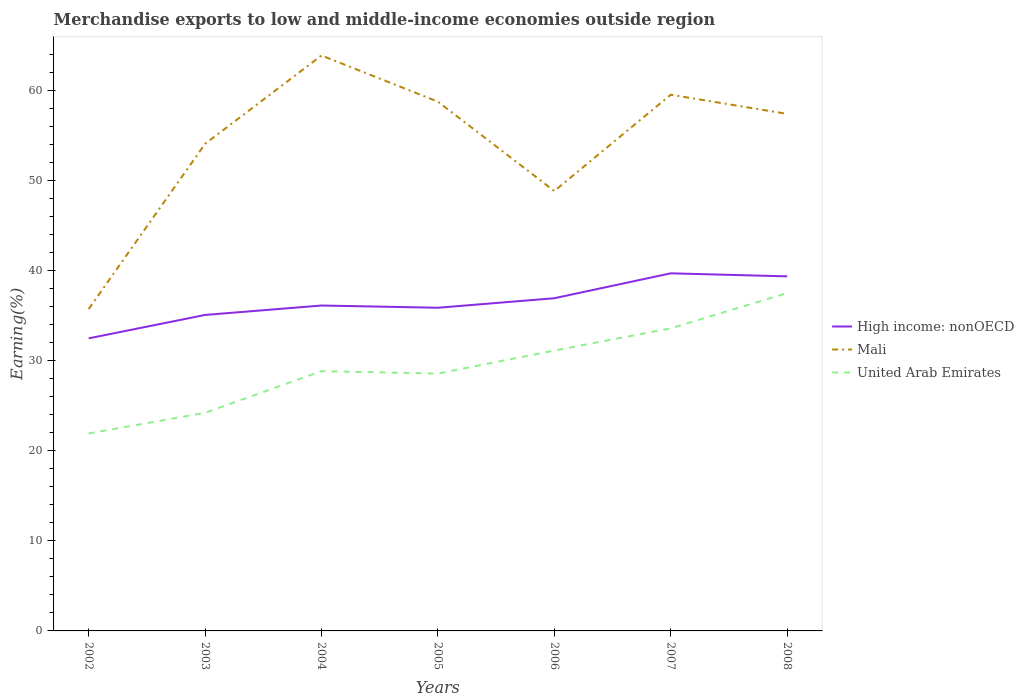Is the number of lines equal to the number of legend labels?
Your response must be concise. Yes. Across all years, what is the maximum percentage of amount earned from merchandise exports in Mali?
Ensure brevity in your answer.  35.72. What is the total percentage of amount earned from merchandise exports in United Arab Emirates in the graph?
Your response must be concise. -4.75. What is the difference between the highest and the second highest percentage of amount earned from merchandise exports in Mali?
Your answer should be compact. 28.14. What is the difference between the highest and the lowest percentage of amount earned from merchandise exports in High income: nonOECD?
Make the answer very short. 3. Is the percentage of amount earned from merchandise exports in High income: nonOECD strictly greater than the percentage of amount earned from merchandise exports in United Arab Emirates over the years?
Provide a short and direct response. No. How many lines are there?
Ensure brevity in your answer.  3. What is the difference between two consecutive major ticks on the Y-axis?
Offer a terse response. 10. Does the graph contain any zero values?
Offer a very short reply. No. Does the graph contain grids?
Ensure brevity in your answer.  No. Where does the legend appear in the graph?
Keep it short and to the point. Center right. How many legend labels are there?
Provide a succinct answer. 3. What is the title of the graph?
Keep it short and to the point. Merchandise exports to low and middle-income economies outside region. Does "Mozambique" appear as one of the legend labels in the graph?
Provide a succinct answer. No. What is the label or title of the X-axis?
Your answer should be compact. Years. What is the label or title of the Y-axis?
Offer a very short reply. Earning(%). What is the Earning(%) in High income: nonOECD in 2002?
Keep it short and to the point. 32.47. What is the Earning(%) of Mali in 2002?
Provide a short and direct response. 35.72. What is the Earning(%) of United Arab Emirates in 2002?
Make the answer very short. 21.91. What is the Earning(%) in High income: nonOECD in 2003?
Provide a short and direct response. 35.07. What is the Earning(%) of Mali in 2003?
Offer a terse response. 54.05. What is the Earning(%) in United Arab Emirates in 2003?
Offer a very short reply. 24.21. What is the Earning(%) of High income: nonOECD in 2004?
Give a very brief answer. 36.11. What is the Earning(%) of Mali in 2004?
Give a very brief answer. 63.86. What is the Earning(%) in United Arab Emirates in 2004?
Your answer should be very brief. 28.83. What is the Earning(%) of High income: nonOECD in 2005?
Keep it short and to the point. 35.87. What is the Earning(%) of Mali in 2005?
Make the answer very short. 58.74. What is the Earning(%) of United Arab Emirates in 2005?
Make the answer very short. 28.56. What is the Earning(%) in High income: nonOECD in 2006?
Offer a very short reply. 36.92. What is the Earning(%) in Mali in 2006?
Provide a succinct answer. 48.82. What is the Earning(%) of United Arab Emirates in 2006?
Provide a short and direct response. 31.12. What is the Earning(%) in High income: nonOECD in 2007?
Your answer should be very brief. 39.69. What is the Earning(%) in Mali in 2007?
Offer a terse response. 59.5. What is the Earning(%) of United Arab Emirates in 2007?
Make the answer very short. 33.58. What is the Earning(%) in High income: nonOECD in 2008?
Ensure brevity in your answer.  39.35. What is the Earning(%) of Mali in 2008?
Provide a succinct answer. 57.38. What is the Earning(%) in United Arab Emirates in 2008?
Your answer should be compact. 37.5. Across all years, what is the maximum Earning(%) in High income: nonOECD?
Provide a short and direct response. 39.69. Across all years, what is the maximum Earning(%) in Mali?
Give a very brief answer. 63.86. Across all years, what is the maximum Earning(%) of United Arab Emirates?
Your answer should be compact. 37.5. Across all years, what is the minimum Earning(%) in High income: nonOECD?
Ensure brevity in your answer.  32.47. Across all years, what is the minimum Earning(%) of Mali?
Provide a succinct answer. 35.72. Across all years, what is the minimum Earning(%) of United Arab Emirates?
Offer a terse response. 21.91. What is the total Earning(%) in High income: nonOECD in the graph?
Keep it short and to the point. 255.47. What is the total Earning(%) in Mali in the graph?
Provide a short and direct response. 378.07. What is the total Earning(%) of United Arab Emirates in the graph?
Your answer should be very brief. 205.7. What is the difference between the Earning(%) of High income: nonOECD in 2002 and that in 2003?
Provide a short and direct response. -2.6. What is the difference between the Earning(%) of Mali in 2002 and that in 2003?
Ensure brevity in your answer.  -18.33. What is the difference between the Earning(%) in United Arab Emirates in 2002 and that in 2003?
Your answer should be very brief. -2.29. What is the difference between the Earning(%) of High income: nonOECD in 2002 and that in 2004?
Offer a terse response. -3.64. What is the difference between the Earning(%) of Mali in 2002 and that in 2004?
Make the answer very short. -28.14. What is the difference between the Earning(%) in United Arab Emirates in 2002 and that in 2004?
Your response must be concise. -6.92. What is the difference between the Earning(%) of High income: nonOECD in 2002 and that in 2005?
Your answer should be very brief. -3.4. What is the difference between the Earning(%) in Mali in 2002 and that in 2005?
Make the answer very short. -23.02. What is the difference between the Earning(%) in United Arab Emirates in 2002 and that in 2005?
Your answer should be compact. -6.65. What is the difference between the Earning(%) of High income: nonOECD in 2002 and that in 2006?
Make the answer very short. -4.45. What is the difference between the Earning(%) of Mali in 2002 and that in 2006?
Your answer should be very brief. -13.1. What is the difference between the Earning(%) of United Arab Emirates in 2002 and that in 2006?
Offer a terse response. -9.2. What is the difference between the Earning(%) of High income: nonOECD in 2002 and that in 2007?
Your answer should be compact. -7.22. What is the difference between the Earning(%) of Mali in 2002 and that in 2007?
Ensure brevity in your answer.  -23.79. What is the difference between the Earning(%) in United Arab Emirates in 2002 and that in 2007?
Offer a terse response. -11.67. What is the difference between the Earning(%) of High income: nonOECD in 2002 and that in 2008?
Provide a succinct answer. -6.88. What is the difference between the Earning(%) in Mali in 2002 and that in 2008?
Provide a short and direct response. -21.66. What is the difference between the Earning(%) in United Arab Emirates in 2002 and that in 2008?
Give a very brief answer. -15.58. What is the difference between the Earning(%) in High income: nonOECD in 2003 and that in 2004?
Your answer should be very brief. -1.05. What is the difference between the Earning(%) in Mali in 2003 and that in 2004?
Offer a terse response. -9.81. What is the difference between the Earning(%) in United Arab Emirates in 2003 and that in 2004?
Keep it short and to the point. -4.62. What is the difference between the Earning(%) in High income: nonOECD in 2003 and that in 2005?
Give a very brief answer. -0.8. What is the difference between the Earning(%) of Mali in 2003 and that in 2005?
Give a very brief answer. -4.68. What is the difference between the Earning(%) in United Arab Emirates in 2003 and that in 2005?
Give a very brief answer. -4.35. What is the difference between the Earning(%) of High income: nonOECD in 2003 and that in 2006?
Ensure brevity in your answer.  -1.86. What is the difference between the Earning(%) in Mali in 2003 and that in 2006?
Keep it short and to the point. 5.23. What is the difference between the Earning(%) of United Arab Emirates in 2003 and that in 2006?
Provide a succinct answer. -6.91. What is the difference between the Earning(%) in High income: nonOECD in 2003 and that in 2007?
Keep it short and to the point. -4.62. What is the difference between the Earning(%) in Mali in 2003 and that in 2007?
Your answer should be compact. -5.45. What is the difference between the Earning(%) of United Arab Emirates in 2003 and that in 2007?
Ensure brevity in your answer.  -9.37. What is the difference between the Earning(%) of High income: nonOECD in 2003 and that in 2008?
Keep it short and to the point. -4.28. What is the difference between the Earning(%) in Mali in 2003 and that in 2008?
Provide a short and direct response. -3.33. What is the difference between the Earning(%) in United Arab Emirates in 2003 and that in 2008?
Your response must be concise. -13.29. What is the difference between the Earning(%) in High income: nonOECD in 2004 and that in 2005?
Offer a terse response. 0.25. What is the difference between the Earning(%) of Mali in 2004 and that in 2005?
Offer a very short reply. 5.13. What is the difference between the Earning(%) in United Arab Emirates in 2004 and that in 2005?
Offer a very short reply. 0.27. What is the difference between the Earning(%) of High income: nonOECD in 2004 and that in 2006?
Keep it short and to the point. -0.81. What is the difference between the Earning(%) of Mali in 2004 and that in 2006?
Ensure brevity in your answer.  15.04. What is the difference between the Earning(%) of United Arab Emirates in 2004 and that in 2006?
Give a very brief answer. -2.29. What is the difference between the Earning(%) of High income: nonOECD in 2004 and that in 2007?
Keep it short and to the point. -3.57. What is the difference between the Earning(%) in Mali in 2004 and that in 2007?
Provide a short and direct response. 4.36. What is the difference between the Earning(%) of United Arab Emirates in 2004 and that in 2007?
Give a very brief answer. -4.75. What is the difference between the Earning(%) in High income: nonOECD in 2004 and that in 2008?
Offer a terse response. -3.24. What is the difference between the Earning(%) of Mali in 2004 and that in 2008?
Keep it short and to the point. 6.48. What is the difference between the Earning(%) in United Arab Emirates in 2004 and that in 2008?
Offer a terse response. -8.67. What is the difference between the Earning(%) of High income: nonOECD in 2005 and that in 2006?
Your response must be concise. -1.06. What is the difference between the Earning(%) of Mali in 2005 and that in 2006?
Keep it short and to the point. 9.92. What is the difference between the Earning(%) in United Arab Emirates in 2005 and that in 2006?
Your answer should be very brief. -2.55. What is the difference between the Earning(%) of High income: nonOECD in 2005 and that in 2007?
Give a very brief answer. -3.82. What is the difference between the Earning(%) in Mali in 2005 and that in 2007?
Provide a short and direct response. -0.77. What is the difference between the Earning(%) of United Arab Emirates in 2005 and that in 2007?
Provide a short and direct response. -5.02. What is the difference between the Earning(%) in High income: nonOECD in 2005 and that in 2008?
Your answer should be very brief. -3.48. What is the difference between the Earning(%) in Mali in 2005 and that in 2008?
Provide a short and direct response. 1.36. What is the difference between the Earning(%) of United Arab Emirates in 2005 and that in 2008?
Keep it short and to the point. -8.94. What is the difference between the Earning(%) in High income: nonOECD in 2006 and that in 2007?
Provide a short and direct response. -2.76. What is the difference between the Earning(%) of Mali in 2006 and that in 2007?
Provide a short and direct response. -10.68. What is the difference between the Earning(%) in United Arab Emirates in 2006 and that in 2007?
Make the answer very short. -2.46. What is the difference between the Earning(%) in High income: nonOECD in 2006 and that in 2008?
Your answer should be very brief. -2.43. What is the difference between the Earning(%) in Mali in 2006 and that in 2008?
Provide a short and direct response. -8.56. What is the difference between the Earning(%) in United Arab Emirates in 2006 and that in 2008?
Provide a short and direct response. -6.38. What is the difference between the Earning(%) of High income: nonOECD in 2007 and that in 2008?
Your answer should be compact. 0.34. What is the difference between the Earning(%) of Mali in 2007 and that in 2008?
Your answer should be very brief. 2.12. What is the difference between the Earning(%) in United Arab Emirates in 2007 and that in 2008?
Make the answer very short. -3.92. What is the difference between the Earning(%) of High income: nonOECD in 2002 and the Earning(%) of Mali in 2003?
Your answer should be compact. -21.58. What is the difference between the Earning(%) in High income: nonOECD in 2002 and the Earning(%) in United Arab Emirates in 2003?
Your response must be concise. 8.26. What is the difference between the Earning(%) in Mali in 2002 and the Earning(%) in United Arab Emirates in 2003?
Give a very brief answer. 11.51. What is the difference between the Earning(%) in High income: nonOECD in 2002 and the Earning(%) in Mali in 2004?
Make the answer very short. -31.39. What is the difference between the Earning(%) of High income: nonOECD in 2002 and the Earning(%) of United Arab Emirates in 2004?
Your answer should be compact. 3.64. What is the difference between the Earning(%) of Mali in 2002 and the Earning(%) of United Arab Emirates in 2004?
Offer a terse response. 6.89. What is the difference between the Earning(%) in High income: nonOECD in 2002 and the Earning(%) in Mali in 2005?
Make the answer very short. -26.27. What is the difference between the Earning(%) of High income: nonOECD in 2002 and the Earning(%) of United Arab Emirates in 2005?
Your answer should be very brief. 3.91. What is the difference between the Earning(%) in Mali in 2002 and the Earning(%) in United Arab Emirates in 2005?
Give a very brief answer. 7.16. What is the difference between the Earning(%) of High income: nonOECD in 2002 and the Earning(%) of Mali in 2006?
Give a very brief answer. -16.35. What is the difference between the Earning(%) of High income: nonOECD in 2002 and the Earning(%) of United Arab Emirates in 2006?
Your answer should be compact. 1.35. What is the difference between the Earning(%) in Mali in 2002 and the Earning(%) in United Arab Emirates in 2006?
Make the answer very short. 4.6. What is the difference between the Earning(%) of High income: nonOECD in 2002 and the Earning(%) of Mali in 2007?
Provide a short and direct response. -27.03. What is the difference between the Earning(%) in High income: nonOECD in 2002 and the Earning(%) in United Arab Emirates in 2007?
Your answer should be very brief. -1.11. What is the difference between the Earning(%) in Mali in 2002 and the Earning(%) in United Arab Emirates in 2007?
Your response must be concise. 2.14. What is the difference between the Earning(%) in High income: nonOECD in 2002 and the Earning(%) in Mali in 2008?
Your answer should be compact. -24.91. What is the difference between the Earning(%) of High income: nonOECD in 2002 and the Earning(%) of United Arab Emirates in 2008?
Give a very brief answer. -5.03. What is the difference between the Earning(%) of Mali in 2002 and the Earning(%) of United Arab Emirates in 2008?
Ensure brevity in your answer.  -1.78. What is the difference between the Earning(%) in High income: nonOECD in 2003 and the Earning(%) in Mali in 2004?
Offer a terse response. -28.8. What is the difference between the Earning(%) in High income: nonOECD in 2003 and the Earning(%) in United Arab Emirates in 2004?
Your response must be concise. 6.24. What is the difference between the Earning(%) in Mali in 2003 and the Earning(%) in United Arab Emirates in 2004?
Make the answer very short. 25.22. What is the difference between the Earning(%) of High income: nonOECD in 2003 and the Earning(%) of Mali in 2005?
Ensure brevity in your answer.  -23.67. What is the difference between the Earning(%) of High income: nonOECD in 2003 and the Earning(%) of United Arab Emirates in 2005?
Your answer should be compact. 6.5. What is the difference between the Earning(%) of Mali in 2003 and the Earning(%) of United Arab Emirates in 2005?
Provide a succinct answer. 25.49. What is the difference between the Earning(%) of High income: nonOECD in 2003 and the Earning(%) of Mali in 2006?
Give a very brief answer. -13.75. What is the difference between the Earning(%) of High income: nonOECD in 2003 and the Earning(%) of United Arab Emirates in 2006?
Make the answer very short. 3.95. What is the difference between the Earning(%) of Mali in 2003 and the Earning(%) of United Arab Emirates in 2006?
Offer a terse response. 22.94. What is the difference between the Earning(%) of High income: nonOECD in 2003 and the Earning(%) of Mali in 2007?
Your answer should be very brief. -24.44. What is the difference between the Earning(%) in High income: nonOECD in 2003 and the Earning(%) in United Arab Emirates in 2007?
Ensure brevity in your answer.  1.49. What is the difference between the Earning(%) in Mali in 2003 and the Earning(%) in United Arab Emirates in 2007?
Your response must be concise. 20.47. What is the difference between the Earning(%) of High income: nonOECD in 2003 and the Earning(%) of Mali in 2008?
Offer a terse response. -22.31. What is the difference between the Earning(%) in High income: nonOECD in 2003 and the Earning(%) in United Arab Emirates in 2008?
Your answer should be very brief. -2.43. What is the difference between the Earning(%) in Mali in 2003 and the Earning(%) in United Arab Emirates in 2008?
Your response must be concise. 16.55. What is the difference between the Earning(%) of High income: nonOECD in 2004 and the Earning(%) of Mali in 2005?
Make the answer very short. -22.62. What is the difference between the Earning(%) of High income: nonOECD in 2004 and the Earning(%) of United Arab Emirates in 2005?
Your answer should be very brief. 7.55. What is the difference between the Earning(%) of Mali in 2004 and the Earning(%) of United Arab Emirates in 2005?
Provide a succinct answer. 35.3. What is the difference between the Earning(%) in High income: nonOECD in 2004 and the Earning(%) in Mali in 2006?
Make the answer very short. -12.71. What is the difference between the Earning(%) in High income: nonOECD in 2004 and the Earning(%) in United Arab Emirates in 2006?
Keep it short and to the point. 5. What is the difference between the Earning(%) of Mali in 2004 and the Earning(%) of United Arab Emirates in 2006?
Your response must be concise. 32.75. What is the difference between the Earning(%) in High income: nonOECD in 2004 and the Earning(%) in Mali in 2007?
Your response must be concise. -23.39. What is the difference between the Earning(%) in High income: nonOECD in 2004 and the Earning(%) in United Arab Emirates in 2007?
Your answer should be very brief. 2.53. What is the difference between the Earning(%) in Mali in 2004 and the Earning(%) in United Arab Emirates in 2007?
Offer a terse response. 30.28. What is the difference between the Earning(%) in High income: nonOECD in 2004 and the Earning(%) in Mali in 2008?
Offer a terse response. -21.27. What is the difference between the Earning(%) of High income: nonOECD in 2004 and the Earning(%) of United Arab Emirates in 2008?
Your answer should be compact. -1.39. What is the difference between the Earning(%) of Mali in 2004 and the Earning(%) of United Arab Emirates in 2008?
Give a very brief answer. 26.36. What is the difference between the Earning(%) of High income: nonOECD in 2005 and the Earning(%) of Mali in 2006?
Your answer should be very brief. -12.95. What is the difference between the Earning(%) in High income: nonOECD in 2005 and the Earning(%) in United Arab Emirates in 2006?
Make the answer very short. 4.75. What is the difference between the Earning(%) in Mali in 2005 and the Earning(%) in United Arab Emirates in 2006?
Provide a succinct answer. 27.62. What is the difference between the Earning(%) of High income: nonOECD in 2005 and the Earning(%) of Mali in 2007?
Your answer should be very brief. -23.64. What is the difference between the Earning(%) of High income: nonOECD in 2005 and the Earning(%) of United Arab Emirates in 2007?
Provide a succinct answer. 2.29. What is the difference between the Earning(%) in Mali in 2005 and the Earning(%) in United Arab Emirates in 2007?
Keep it short and to the point. 25.16. What is the difference between the Earning(%) in High income: nonOECD in 2005 and the Earning(%) in Mali in 2008?
Make the answer very short. -21.51. What is the difference between the Earning(%) in High income: nonOECD in 2005 and the Earning(%) in United Arab Emirates in 2008?
Offer a very short reply. -1.63. What is the difference between the Earning(%) in Mali in 2005 and the Earning(%) in United Arab Emirates in 2008?
Ensure brevity in your answer.  21.24. What is the difference between the Earning(%) of High income: nonOECD in 2006 and the Earning(%) of Mali in 2007?
Your answer should be compact. -22.58. What is the difference between the Earning(%) in High income: nonOECD in 2006 and the Earning(%) in United Arab Emirates in 2007?
Your answer should be compact. 3.34. What is the difference between the Earning(%) in Mali in 2006 and the Earning(%) in United Arab Emirates in 2007?
Ensure brevity in your answer.  15.24. What is the difference between the Earning(%) of High income: nonOECD in 2006 and the Earning(%) of Mali in 2008?
Your answer should be very brief. -20.46. What is the difference between the Earning(%) of High income: nonOECD in 2006 and the Earning(%) of United Arab Emirates in 2008?
Give a very brief answer. -0.58. What is the difference between the Earning(%) of Mali in 2006 and the Earning(%) of United Arab Emirates in 2008?
Provide a short and direct response. 11.32. What is the difference between the Earning(%) in High income: nonOECD in 2007 and the Earning(%) in Mali in 2008?
Your answer should be compact. -17.69. What is the difference between the Earning(%) in High income: nonOECD in 2007 and the Earning(%) in United Arab Emirates in 2008?
Offer a terse response. 2.19. What is the difference between the Earning(%) in Mali in 2007 and the Earning(%) in United Arab Emirates in 2008?
Provide a short and direct response. 22.01. What is the average Earning(%) of High income: nonOECD per year?
Keep it short and to the point. 36.5. What is the average Earning(%) in Mali per year?
Give a very brief answer. 54.01. What is the average Earning(%) in United Arab Emirates per year?
Your answer should be very brief. 29.39. In the year 2002, what is the difference between the Earning(%) of High income: nonOECD and Earning(%) of Mali?
Your answer should be very brief. -3.25. In the year 2002, what is the difference between the Earning(%) in High income: nonOECD and Earning(%) in United Arab Emirates?
Give a very brief answer. 10.56. In the year 2002, what is the difference between the Earning(%) of Mali and Earning(%) of United Arab Emirates?
Provide a succinct answer. 13.8. In the year 2003, what is the difference between the Earning(%) in High income: nonOECD and Earning(%) in Mali?
Keep it short and to the point. -18.99. In the year 2003, what is the difference between the Earning(%) in High income: nonOECD and Earning(%) in United Arab Emirates?
Offer a terse response. 10.86. In the year 2003, what is the difference between the Earning(%) of Mali and Earning(%) of United Arab Emirates?
Your response must be concise. 29.85. In the year 2004, what is the difference between the Earning(%) of High income: nonOECD and Earning(%) of Mali?
Ensure brevity in your answer.  -27.75. In the year 2004, what is the difference between the Earning(%) in High income: nonOECD and Earning(%) in United Arab Emirates?
Provide a succinct answer. 7.28. In the year 2004, what is the difference between the Earning(%) of Mali and Earning(%) of United Arab Emirates?
Keep it short and to the point. 35.03. In the year 2005, what is the difference between the Earning(%) in High income: nonOECD and Earning(%) in Mali?
Offer a terse response. -22.87. In the year 2005, what is the difference between the Earning(%) in High income: nonOECD and Earning(%) in United Arab Emirates?
Provide a short and direct response. 7.3. In the year 2005, what is the difference between the Earning(%) of Mali and Earning(%) of United Arab Emirates?
Your answer should be very brief. 30.17. In the year 2006, what is the difference between the Earning(%) in High income: nonOECD and Earning(%) in Mali?
Offer a terse response. -11.9. In the year 2006, what is the difference between the Earning(%) in High income: nonOECD and Earning(%) in United Arab Emirates?
Your answer should be compact. 5.81. In the year 2006, what is the difference between the Earning(%) in Mali and Earning(%) in United Arab Emirates?
Your answer should be compact. 17.7. In the year 2007, what is the difference between the Earning(%) of High income: nonOECD and Earning(%) of Mali?
Your answer should be very brief. -19.82. In the year 2007, what is the difference between the Earning(%) of High income: nonOECD and Earning(%) of United Arab Emirates?
Provide a short and direct response. 6.11. In the year 2007, what is the difference between the Earning(%) of Mali and Earning(%) of United Arab Emirates?
Your answer should be compact. 25.92. In the year 2008, what is the difference between the Earning(%) in High income: nonOECD and Earning(%) in Mali?
Your answer should be compact. -18.03. In the year 2008, what is the difference between the Earning(%) of High income: nonOECD and Earning(%) of United Arab Emirates?
Your response must be concise. 1.85. In the year 2008, what is the difference between the Earning(%) of Mali and Earning(%) of United Arab Emirates?
Provide a succinct answer. 19.88. What is the ratio of the Earning(%) in High income: nonOECD in 2002 to that in 2003?
Offer a terse response. 0.93. What is the ratio of the Earning(%) of Mali in 2002 to that in 2003?
Your answer should be very brief. 0.66. What is the ratio of the Earning(%) in United Arab Emirates in 2002 to that in 2003?
Give a very brief answer. 0.91. What is the ratio of the Earning(%) in High income: nonOECD in 2002 to that in 2004?
Ensure brevity in your answer.  0.9. What is the ratio of the Earning(%) of Mali in 2002 to that in 2004?
Provide a succinct answer. 0.56. What is the ratio of the Earning(%) in United Arab Emirates in 2002 to that in 2004?
Make the answer very short. 0.76. What is the ratio of the Earning(%) of High income: nonOECD in 2002 to that in 2005?
Your response must be concise. 0.91. What is the ratio of the Earning(%) in Mali in 2002 to that in 2005?
Provide a short and direct response. 0.61. What is the ratio of the Earning(%) in United Arab Emirates in 2002 to that in 2005?
Your answer should be compact. 0.77. What is the ratio of the Earning(%) of High income: nonOECD in 2002 to that in 2006?
Make the answer very short. 0.88. What is the ratio of the Earning(%) of Mali in 2002 to that in 2006?
Provide a short and direct response. 0.73. What is the ratio of the Earning(%) of United Arab Emirates in 2002 to that in 2006?
Keep it short and to the point. 0.7. What is the ratio of the Earning(%) in High income: nonOECD in 2002 to that in 2007?
Ensure brevity in your answer.  0.82. What is the ratio of the Earning(%) of Mali in 2002 to that in 2007?
Your response must be concise. 0.6. What is the ratio of the Earning(%) of United Arab Emirates in 2002 to that in 2007?
Provide a succinct answer. 0.65. What is the ratio of the Earning(%) in High income: nonOECD in 2002 to that in 2008?
Your answer should be compact. 0.83. What is the ratio of the Earning(%) of Mali in 2002 to that in 2008?
Make the answer very short. 0.62. What is the ratio of the Earning(%) in United Arab Emirates in 2002 to that in 2008?
Make the answer very short. 0.58. What is the ratio of the Earning(%) in Mali in 2003 to that in 2004?
Offer a very short reply. 0.85. What is the ratio of the Earning(%) of United Arab Emirates in 2003 to that in 2004?
Offer a terse response. 0.84. What is the ratio of the Earning(%) in High income: nonOECD in 2003 to that in 2005?
Give a very brief answer. 0.98. What is the ratio of the Earning(%) in Mali in 2003 to that in 2005?
Your answer should be very brief. 0.92. What is the ratio of the Earning(%) in United Arab Emirates in 2003 to that in 2005?
Offer a very short reply. 0.85. What is the ratio of the Earning(%) of High income: nonOECD in 2003 to that in 2006?
Your answer should be very brief. 0.95. What is the ratio of the Earning(%) of Mali in 2003 to that in 2006?
Provide a short and direct response. 1.11. What is the ratio of the Earning(%) of United Arab Emirates in 2003 to that in 2006?
Offer a very short reply. 0.78. What is the ratio of the Earning(%) of High income: nonOECD in 2003 to that in 2007?
Offer a terse response. 0.88. What is the ratio of the Earning(%) in Mali in 2003 to that in 2007?
Give a very brief answer. 0.91. What is the ratio of the Earning(%) of United Arab Emirates in 2003 to that in 2007?
Offer a terse response. 0.72. What is the ratio of the Earning(%) of High income: nonOECD in 2003 to that in 2008?
Your answer should be compact. 0.89. What is the ratio of the Earning(%) of Mali in 2003 to that in 2008?
Provide a short and direct response. 0.94. What is the ratio of the Earning(%) of United Arab Emirates in 2003 to that in 2008?
Offer a terse response. 0.65. What is the ratio of the Earning(%) of Mali in 2004 to that in 2005?
Give a very brief answer. 1.09. What is the ratio of the Earning(%) in United Arab Emirates in 2004 to that in 2005?
Keep it short and to the point. 1.01. What is the ratio of the Earning(%) in High income: nonOECD in 2004 to that in 2006?
Keep it short and to the point. 0.98. What is the ratio of the Earning(%) of Mali in 2004 to that in 2006?
Your response must be concise. 1.31. What is the ratio of the Earning(%) in United Arab Emirates in 2004 to that in 2006?
Make the answer very short. 0.93. What is the ratio of the Earning(%) in High income: nonOECD in 2004 to that in 2007?
Make the answer very short. 0.91. What is the ratio of the Earning(%) of Mali in 2004 to that in 2007?
Your response must be concise. 1.07. What is the ratio of the Earning(%) in United Arab Emirates in 2004 to that in 2007?
Keep it short and to the point. 0.86. What is the ratio of the Earning(%) in High income: nonOECD in 2004 to that in 2008?
Offer a terse response. 0.92. What is the ratio of the Earning(%) in Mali in 2004 to that in 2008?
Provide a succinct answer. 1.11. What is the ratio of the Earning(%) in United Arab Emirates in 2004 to that in 2008?
Your response must be concise. 0.77. What is the ratio of the Earning(%) of High income: nonOECD in 2005 to that in 2006?
Your response must be concise. 0.97. What is the ratio of the Earning(%) in Mali in 2005 to that in 2006?
Your answer should be very brief. 1.2. What is the ratio of the Earning(%) in United Arab Emirates in 2005 to that in 2006?
Your answer should be very brief. 0.92. What is the ratio of the Earning(%) of High income: nonOECD in 2005 to that in 2007?
Give a very brief answer. 0.9. What is the ratio of the Earning(%) of Mali in 2005 to that in 2007?
Offer a terse response. 0.99. What is the ratio of the Earning(%) of United Arab Emirates in 2005 to that in 2007?
Offer a terse response. 0.85. What is the ratio of the Earning(%) in High income: nonOECD in 2005 to that in 2008?
Your answer should be compact. 0.91. What is the ratio of the Earning(%) of Mali in 2005 to that in 2008?
Offer a terse response. 1.02. What is the ratio of the Earning(%) in United Arab Emirates in 2005 to that in 2008?
Make the answer very short. 0.76. What is the ratio of the Earning(%) in High income: nonOECD in 2006 to that in 2007?
Keep it short and to the point. 0.93. What is the ratio of the Earning(%) in Mali in 2006 to that in 2007?
Ensure brevity in your answer.  0.82. What is the ratio of the Earning(%) in United Arab Emirates in 2006 to that in 2007?
Give a very brief answer. 0.93. What is the ratio of the Earning(%) of High income: nonOECD in 2006 to that in 2008?
Offer a terse response. 0.94. What is the ratio of the Earning(%) of Mali in 2006 to that in 2008?
Provide a succinct answer. 0.85. What is the ratio of the Earning(%) of United Arab Emirates in 2006 to that in 2008?
Give a very brief answer. 0.83. What is the ratio of the Earning(%) of High income: nonOECD in 2007 to that in 2008?
Offer a terse response. 1.01. What is the ratio of the Earning(%) of United Arab Emirates in 2007 to that in 2008?
Provide a short and direct response. 0.9. What is the difference between the highest and the second highest Earning(%) in High income: nonOECD?
Make the answer very short. 0.34. What is the difference between the highest and the second highest Earning(%) of Mali?
Offer a very short reply. 4.36. What is the difference between the highest and the second highest Earning(%) in United Arab Emirates?
Keep it short and to the point. 3.92. What is the difference between the highest and the lowest Earning(%) of High income: nonOECD?
Keep it short and to the point. 7.22. What is the difference between the highest and the lowest Earning(%) of Mali?
Your response must be concise. 28.14. What is the difference between the highest and the lowest Earning(%) of United Arab Emirates?
Your response must be concise. 15.58. 